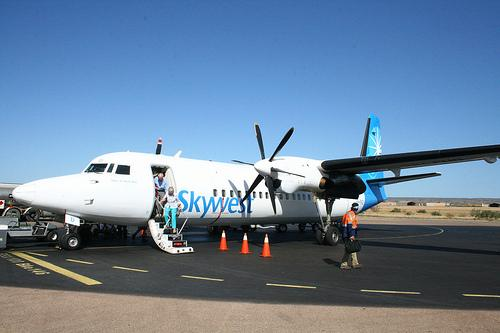What is the state of the airplane engine in the image? The airplane engine is idle with black rotors. Give a brief description of the lines painted on the ground in front of the airplane. There are yellow stripes in front of the airplane. Mention the color of the tail and propeller of the airplane. The tail of the airplane is blue and the propeller is black. What type of area is the scene taking place in and describe its surface? The scene is taking place at an airport on dark black asphalt. How many people are visible in the image and what are they doing? Multiple people are visible; they are unloading, carrying bags, and walking away from the airplane. Identify the color and type of the airplane in the image. The airplane is a white Skywest private airplane. Explain the function of the ladders in the image. The ladders provide easy plane access for passengers and crew members. Describe the condition of the sky in the image and how it affects the atmosphere. The clear blue skies make for a beautiful day and a pleasant atmosphere. Briefly describe the scene taking place on the ground in front of the airplane. There are passengers walking out of the plane, a man carrying a bag, and orange cones on the runway. What is the weather like in the image? The weather is clear with blue skies. Find the six pineapple trees on the left side of the photo. No, it's not mentioned in the image. Can you count the twenty-five airplane windows on the left side of the plane? The airplane is described as small and the windows on the plane are in a section of "some windows", suggesting that there aren't twenty-five windows on the left side. Is the sky full of white fluffy clouds? The sky is described as clear blue skies, which indicates that there are no clouds. Is the airplane in the photo purple and yellow? The airplane is described as a white skywest private airplane, not purple and yellow. 